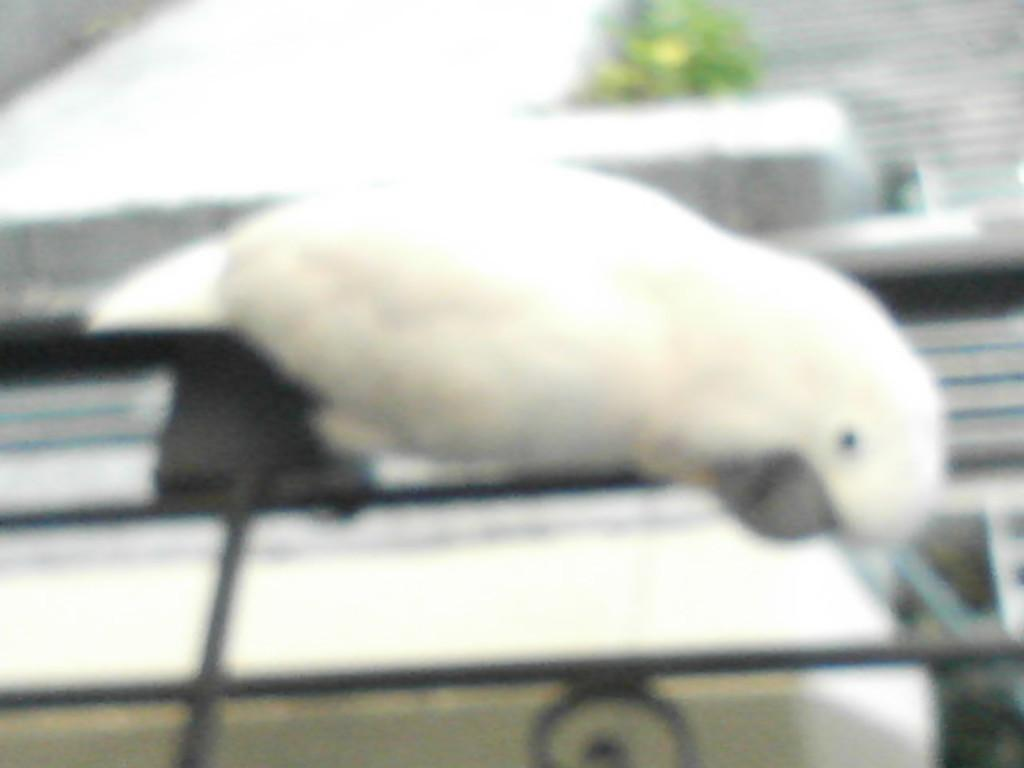What type of structure is depicted by the iron bars in the image? The iron bars in the image could be part of a cage or a fence. What animal is sitting on the iron bars? There is a white color parrot on the iron bars. Can you describe the overall quality of the image? The image is blurred. What type of cakes are being served on the table in the image? There is no table or cakes present in the image; it features iron bars with a parrot on them. Is the woman in the image wearing a red dress? There is no woman present in the image. 